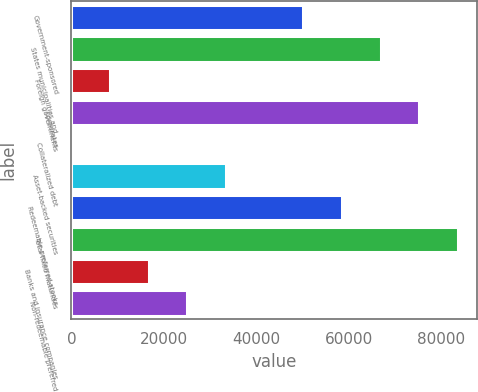Convert chart to OTSL. <chart><loc_0><loc_0><loc_500><loc_500><bar_chart><fcel>Government-sponsored<fcel>States municipalities and<fcel>Foreign governments<fcel>Corporates<fcel>Collateralized debt<fcel>Asset-backed securities<fcel>Redeemable preferred stocks<fcel>Total fixed maturities<fcel>Banks and insurance companies<fcel>Non-redeemable preferred<nl><fcel>50203.5<fcel>66936.7<fcel>8370.47<fcel>75303.4<fcel>3.86<fcel>33470.3<fcel>58570.1<fcel>83670<fcel>16737.1<fcel>25103.7<nl></chart> 